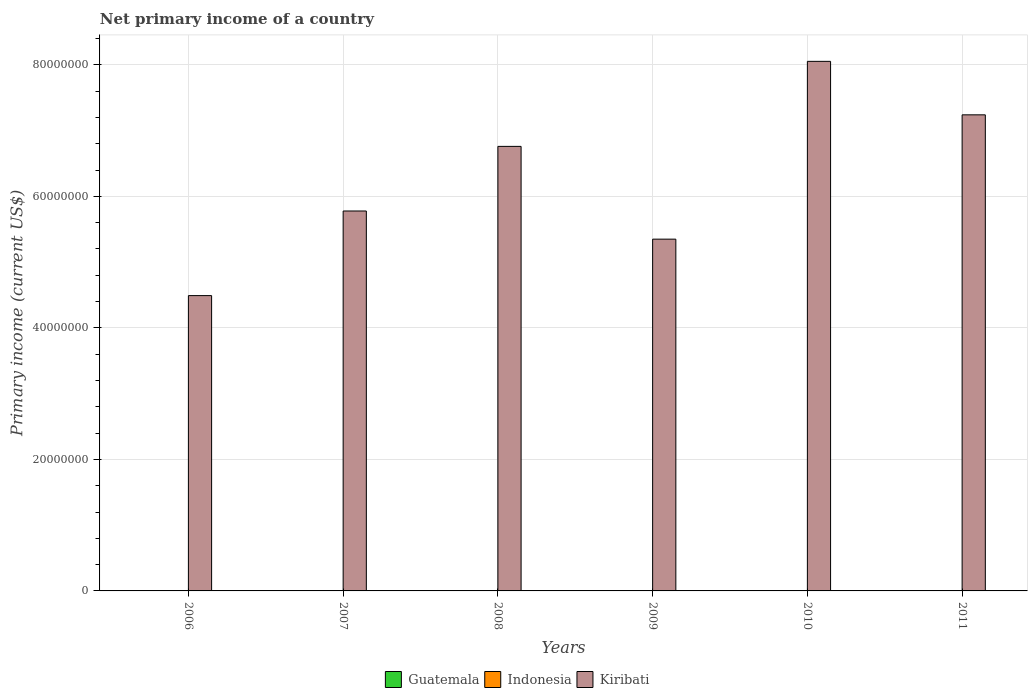How many different coloured bars are there?
Ensure brevity in your answer.  1. Are the number of bars per tick equal to the number of legend labels?
Your answer should be compact. No. What is the primary income in Kiribati in 2010?
Your answer should be compact. 8.05e+07. Across all years, what is the maximum primary income in Kiribati?
Ensure brevity in your answer.  8.05e+07. Across all years, what is the minimum primary income in Guatemala?
Give a very brief answer. 0. What is the total primary income in Kiribati in the graph?
Offer a terse response. 3.77e+08. What is the difference between the primary income in Kiribati in 2009 and that in 2011?
Ensure brevity in your answer.  -1.89e+07. What is the difference between the primary income in Kiribati in 2007 and the primary income in Guatemala in 2006?
Make the answer very short. 5.78e+07. In how many years, is the primary income in Guatemala greater than 44000000 US$?
Provide a succinct answer. 0. What is the ratio of the primary income in Kiribati in 2010 to that in 2011?
Provide a succinct answer. 1.11. What is the difference between the highest and the second highest primary income in Kiribati?
Offer a very short reply. 8.13e+06. What is the difference between the highest and the lowest primary income in Kiribati?
Give a very brief answer. 3.56e+07. Is the sum of the primary income in Kiribati in 2009 and 2011 greater than the maximum primary income in Guatemala across all years?
Your answer should be compact. Yes. Is it the case that in every year, the sum of the primary income in Guatemala and primary income in Indonesia is greater than the primary income in Kiribati?
Your response must be concise. No. Are all the bars in the graph horizontal?
Make the answer very short. No. Are the values on the major ticks of Y-axis written in scientific E-notation?
Provide a succinct answer. No. Does the graph contain grids?
Offer a terse response. Yes. Where does the legend appear in the graph?
Your response must be concise. Bottom center. How are the legend labels stacked?
Offer a very short reply. Horizontal. What is the title of the graph?
Offer a terse response. Net primary income of a country. Does "Egypt, Arab Rep." appear as one of the legend labels in the graph?
Keep it short and to the point. No. What is the label or title of the Y-axis?
Your answer should be very brief. Primary income (current US$). What is the Primary income (current US$) in Guatemala in 2006?
Offer a very short reply. 0. What is the Primary income (current US$) in Kiribati in 2006?
Ensure brevity in your answer.  4.49e+07. What is the Primary income (current US$) in Guatemala in 2007?
Your response must be concise. 0. What is the Primary income (current US$) in Kiribati in 2007?
Make the answer very short. 5.78e+07. What is the Primary income (current US$) in Kiribati in 2008?
Provide a short and direct response. 6.76e+07. What is the Primary income (current US$) of Guatemala in 2009?
Provide a short and direct response. 0. What is the Primary income (current US$) in Kiribati in 2009?
Your answer should be compact. 5.35e+07. What is the Primary income (current US$) of Guatemala in 2010?
Give a very brief answer. 0. What is the Primary income (current US$) in Kiribati in 2010?
Keep it short and to the point. 8.05e+07. What is the Primary income (current US$) of Guatemala in 2011?
Provide a succinct answer. 0. What is the Primary income (current US$) in Indonesia in 2011?
Your response must be concise. 0. What is the Primary income (current US$) of Kiribati in 2011?
Offer a very short reply. 7.24e+07. Across all years, what is the maximum Primary income (current US$) of Kiribati?
Provide a succinct answer. 8.05e+07. Across all years, what is the minimum Primary income (current US$) of Kiribati?
Offer a terse response. 4.49e+07. What is the total Primary income (current US$) of Kiribati in the graph?
Provide a short and direct response. 3.77e+08. What is the difference between the Primary income (current US$) of Kiribati in 2006 and that in 2007?
Keep it short and to the point. -1.29e+07. What is the difference between the Primary income (current US$) in Kiribati in 2006 and that in 2008?
Your response must be concise. -2.27e+07. What is the difference between the Primary income (current US$) of Kiribati in 2006 and that in 2009?
Provide a short and direct response. -8.59e+06. What is the difference between the Primary income (current US$) in Kiribati in 2006 and that in 2010?
Your response must be concise. -3.56e+07. What is the difference between the Primary income (current US$) of Kiribati in 2006 and that in 2011?
Keep it short and to the point. -2.75e+07. What is the difference between the Primary income (current US$) in Kiribati in 2007 and that in 2008?
Your response must be concise. -9.83e+06. What is the difference between the Primary income (current US$) of Kiribati in 2007 and that in 2009?
Offer a terse response. 4.28e+06. What is the difference between the Primary income (current US$) in Kiribati in 2007 and that in 2010?
Give a very brief answer. -2.28e+07. What is the difference between the Primary income (current US$) in Kiribati in 2007 and that in 2011?
Your answer should be very brief. -1.46e+07. What is the difference between the Primary income (current US$) of Kiribati in 2008 and that in 2009?
Your response must be concise. 1.41e+07. What is the difference between the Primary income (current US$) in Kiribati in 2008 and that in 2010?
Your answer should be compact. -1.29e+07. What is the difference between the Primary income (current US$) of Kiribati in 2008 and that in 2011?
Your response must be concise. -4.80e+06. What is the difference between the Primary income (current US$) in Kiribati in 2009 and that in 2010?
Your response must be concise. -2.70e+07. What is the difference between the Primary income (current US$) of Kiribati in 2009 and that in 2011?
Give a very brief answer. -1.89e+07. What is the difference between the Primary income (current US$) of Kiribati in 2010 and that in 2011?
Ensure brevity in your answer.  8.13e+06. What is the average Primary income (current US$) in Indonesia per year?
Give a very brief answer. 0. What is the average Primary income (current US$) of Kiribati per year?
Offer a terse response. 6.28e+07. What is the ratio of the Primary income (current US$) of Kiribati in 2006 to that in 2007?
Your response must be concise. 0.78. What is the ratio of the Primary income (current US$) in Kiribati in 2006 to that in 2008?
Your answer should be very brief. 0.66. What is the ratio of the Primary income (current US$) in Kiribati in 2006 to that in 2009?
Ensure brevity in your answer.  0.84. What is the ratio of the Primary income (current US$) of Kiribati in 2006 to that in 2010?
Give a very brief answer. 0.56. What is the ratio of the Primary income (current US$) of Kiribati in 2006 to that in 2011?
Ensure brevity in your answer.  0.62. What is the ratio of the Primary income (current US$) of Kiribati in 2007 to that in 2008?
Your response must be concise. 0.85. What is the ratio of the Primary income (current US$) in Kiribati in 2007 to that in 2009?
Offer a terse response. 1.08. What is the ratio of the Primary income (current US$) of Kiribati in 2007 to that in 2010?
Give a very brief answer. 0.72. What is the ratio of the Primary income (current US$) of Kiribati in 2007 to that in 2011?
Keep it short and to the point. 0.8. What is the ratio of the Primary income (current US$) of Kiribati in 2008 to that in 2009?
Your answer should be compact. 1.26. What is the ratio of the Primary income (current US$) of Kiribati in 2008 to that in 2010?
Offer a very short reply. 0.84. What is the ratio of the Primary income (current US$) in Kiribati in 2008 to that in 2011?
Your answer should be compact. 0.93. What is the ratio of the Primary income (current US$) in Kiribati in 2009 to that in 2010?
Provide a succinct answer. 0.66. What is the ratio of the Primary income (current US$) of Kiribati in 2009 to that in 2011?
Your answer should be compact. 0.74. What is the ratio of the Primary income (current US$) in Kiribati in 2010 to that in 2011?
Provide a succinct answer. 1.11. What is the difference between the highest and the second highest Primary income (current US$) in Kiribati?
Provide a short and direct response. 8.13e+06. What is the difference between the highest and the lowest Primary income (current US$) of Kiribati?
Provide a short and direct response. 3.56e+07. 